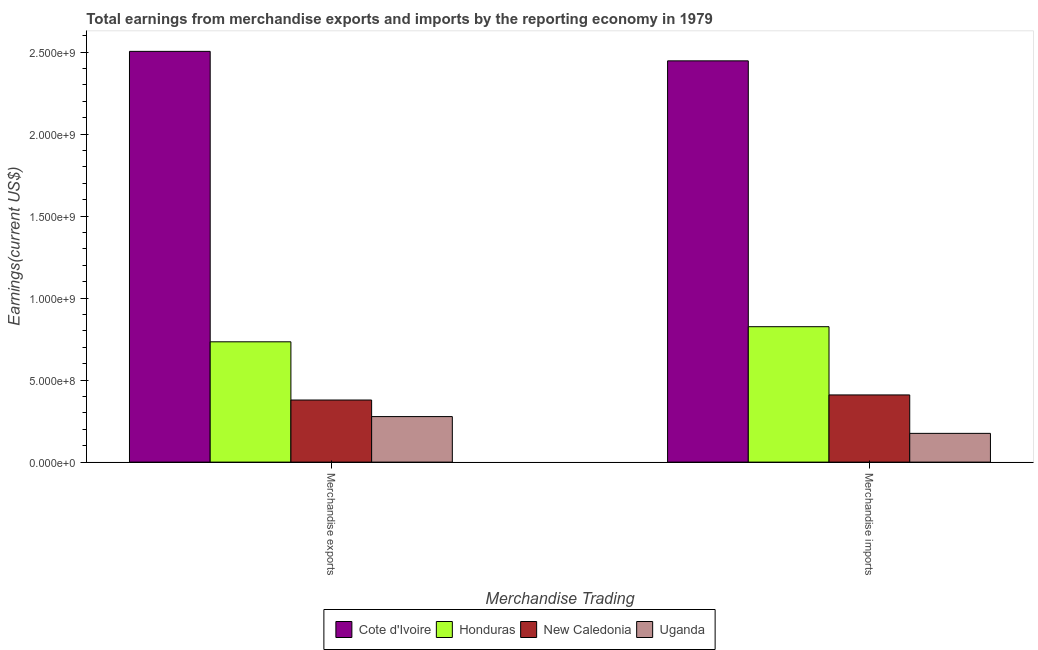How many different coloured bars are there?
Your answer should be very brief. 4. Are the number of bars on each tick of the X-axis equal?
Make the answer very short. Yes. What is the earnings from merchandise exports in Honduras?
Your response must be concise. 7.34e+08. Across all countries, what is the maximum earnings from merchandise exports?
Give a very brief answer. 2.50e+09. Across all countries, what is the minimum earnings from merchandise imports?
Provide a succinct answer. 1.75e+08. In which country was the earnings from merchandise imports maximum?
Your response must be concise. Cote d'Ivoire. In which country was the earnings from merchandise exports minimum?
Make the answer very short. Uganda. What is the total earnings from merchandise imports in the graph?
Your answer should be very brief. 3.86e+09. What is the difference between the earnings from merchandise exports in Uganda and that in Cote d'Ivoire?
Your answer should be compact. -2.23e+09. What is the difference between the earnings from merchandise exports in Cote d'Ivoire and the earnings from merchandise imports in New Caledonia?
Ensure brevity in your answer.  2.09e+09. What is the average earnings from merchandise exports per country?
Offer a terse response. 9.74e+08. What is the difference between the earnings from merchandise imports and earnings from merchandise exports in Honduras?
Ensure brevity in your answer.  9.21e+07. In how many countries, is the earnings from merchandise imports greater than 1100000000 US$?
Give a very brief answer. 1. What is the ratio of the earnings from merchandise exports in New Caledonia to that in Cote d'Ivoire?
Offer a very short reply. 0.15. Is the earnings from merchandise exports in New Caledonia less than that in Cote d'Ivoire?
Provide a succinct answer. Yes. What does the 1st bar from the left in Merchandise imports represents?
Offer a terse response. Cote d'Ivoire. What does the 4th bar from the right in Merchandise exports represents?
Your answer should be compact. Cote d'Ivoire. Are all the bars in the graph horizontal?
Your response must be concise. No. Are the values on the major ticks of Y-axis written in scientific E-notation?
Offer a very short reply. Yes. Does the graph contain any zero values?
Your response must be concise. No. Does the graph contain grids?
Keep it short and to the point. No. Where does the legend appear in the graph?
Make the answer very short. Bottom center. What is the title of the graph?
Ensure brevity in your answer.  Total earnings from merchandise exports and imports by the reporting economy in 1979. Does "United States" appear as one of the legend labels in the graph?
Ensure brevity in your answer.  No. What is the label or title of the X-axis?
Provide a short and direct response. Merchandise Trading. What is the label or title of the Y-axis?
Offer a terse response. Earnings(current US$). What is the Earnings(current US$) of Cote d'Ivoire in Merchandise exports?
Keep it short and to the point. 2.50e+09. What is the Earnings(current US$) in Honduras in Merchandise exports?
Give a very brief answer. 7.34e+08. What is the Earnings(current US$) in New Caledonia in Merchandise exports?
Provide a short and direct response. 3.79e+08. What is the Earnings(current US$) of Uganda in Merchandise exports?
Ensure brevity in your answer.  2.78e+08. What is the Earnings(current US$) of Cote d'Ivoire in Merchandise imports?
Make the answer very short. 2.45e+09. What is the Earnings(current US$) of Honduras in Merchandise imports?
Keep it short and to the point. 8.26e+08. What is the Earnings(current US$) of New Caledonia in Merchandise imports?
Provide a succinct answer. 4.10e+08. What is the Earnings(current US$) in Uganda in Merchandise imports?
Your response must be concise. 1.75e+08. Across all Merchandise Trading, what is the maximum Earnings(current US$) of Cote d'Ivoire?
Offer a terse response. 2.50e+09. Across all Merchandise Trading, what is the maximum Earnings(current US$) in Honduras?
Give a very brief answer. 8.26e+08. Across all Merchandise Trading, what is the maximum Earnings(current US$) in New Caledonia?
Keep it short and to the point. 4.10e+08. Across all Merchandise Trading, what is the maximum Earnings(current US$) of Uganda?
Keep it short and to the point. 2.78e+08. Across all Merchandise Trading, what is the minimum Earnings(current US$) in Cote d'Ivoire?
Make the answer very short. 2.45e+09. Across all Merchandise Trading, what is the minimum Earnings(current US$) in Honduras?
Keep it short and to the point. 7.34e+08. Across all Merchandise Trading, what is the minimum Earnings(current US$) of New Caledonia?
Give a very brief answer. 3.79e+08. Across all Merchandise Trading, what is the minimum Earnings(current US$) in Uganda?
Keep it short and to the point. 1.75e+08. What is the total Earnings(current US$) in Cote d'Ivoire in the graph?
Provide a succinct answer. 4.95e+09. What is the total Earnings(current US$) of Honduras in the graph?
Give a very brief answer. 1.56e+09. What is the total Earnings(current US$) in New Caledonia in the graph?
Keep it short and to the point. 7.88e+08. What is the total Earnings(current US$) in Uganda in the graph?
Provide a short and direct response. 4.53e+08. What is the difference between the Earnings(current US$) of Cote d'Ivoire in Merchandise exports and that in Merchandise imports?
Offer a very short reply. 5.79e+07. What is the difference between the Earnings(current US$) of Honduras in Merchandise exports and that in Merchandise imports?
Your answer should be compact. -9.21e+07. What is the difference between the Earnings(current US$) in New Caledonia in Merchandise exports and that in Merchandise imports?
Give a very brief answer. -3.11e+07. What is the difference between the Earnings(current US$) of Uganda in Merchandise exports and that in Merchandise imports?
Offer a terse response. 1.02e+08. What is the difference between the Earnings(current US$) of Cote d'Ivoire in Merchandise exports and the Earnings(current US$) of Honduras in Merchandise imports?
Your answer should be very brief. 1.68e+09. What is the difference between the Earnings(current US$) in Cote d'Ivoire in Merchandise exports and the Earnings(current US$) in New Caledonia in Merchandise imports?
Provide a short and direct response. 2.09e+09. What is the difference between the Earnings(current US$) in Cote d'Ivoire in Merchandise exports and the Earnings(current US$) in Uganda in Merchandise imports?
Make the answer very short. 2.33e+09. What is the difference between the Earnings(current US$) in Honduras in Merchandise exports and the Earnings(current US$) in New Caledonia in Merchandise imports?
Offer a very short reply. 3.24e+08. What is the difference between the Earnings(current US$) in Honduras in Merchandise exports and the Earnings(current US$) in Uganda in Merchandise imports?
Give a very brief answer. 5.58e+08. What is the difference between the Earnings(current US$) in New Caledonia in Merchandise exports and the Earnings(current US$) in Uganda in Merchandise imports?
Provide a succinct answer. 2.03e+08. What is the average Earnings(current US$) in Cote d'Ivoire per Merchandise Trading?
Provide a short and direct response. 2.48e+09. What is the average Earnings(current US$) of Honduras per Merchandise Trading?
Make the answer very short. 7.80e+08. What is the average Earnings(current US$) of New Caledonia per Merchandise Trading?
Offer a very short reply. 3.94e+08. What is the average Earnings(current US$) in Uganda per Merchandise Trading?
Keep it short and to the point. 2.27e+08. What is the difference between the Earnings(current US$) of Cote d'Ivoire and Earnings(current US$) of Honduras in Merchandise exports?
Offer a terse response. 1.77e+09. What is the difference between the Earnings(current US$) of Cote d'Ivoire and Earnings(current US$) of New Caledonia in Merchandise exports?
Ensure brevity in your answer.  2.13e+09. What is the difference between the Earnings(current US$) of Cote d'Ivoire and Earnings(current US$) of Uganda in Merchandise exports?
Offer a very short reply. 2.23e+09. What is the difference between the Earnings(current US$) of Honduras and Earnings(current US$) of New Caledonia in Merchandise exports?
Provide a succinct answer. 3.55e+08. What is the difference between the Earnings(current US$) of Honduras and Earnings(current US$) of Uganda in Merchandise exports?
Offer a terse response. 4.56e+08. What is the difference between the Earnings(current US$) of New Caledonia and Earnings(current US$) of Uganda in Merchandise exports?
Provide a succinct answer. 1.01e+08. What is the difference between the Earnings(current US$) in Cote d'Ivoire and Earnings(current US$) in Honduras in Merchandise imports?
Make the answer very short. 1.62e+09. What is the difference between the Earnings(current US$) in Cote d'Ivoire and Earnings(current US$) in New Caledonia in Merchandise imports?
Your answer should be very brief. 2.04e+09. What is the difference between the Earnings(current US$) of Cote d'Ivoire and Earnings(current US$) of Uganda in Merchandise imports?
Ensure brevity in your answer.  2.27e+09. What is the difference between the Earnings(current US$) of Honduras and Earnings(current US$) of New Caledonia in Merchandise imports?
Provide a short and direct response. 4.16e+08. What is the difference between the Earnings(current US$) in Honduras and Earnings(current US$) in Uganda in Merchandise imports?
Give a very brief answer. 6.50e+08. What is the difference between the Earnings(current US$) of New Caledonia and Earnings(current US$) of Uganda in Merchandise imports?
Keep it short and to the point. 2.34e+08. What is the ratio of the Earnings(current US$) of Cote d'Ivoire in Merchandise exports to that in Merchandise imports?
Your response must be concise. 1.02. What is the ratio of the Earnings(current US$) in Honduras in Merchandise exports to that in Merchandise imports?
Your answer should be very brief. 0.89. What is the ratio of the Earnings(current US$) in New Caledonia in Merchandise exports to that in Merchandise imports?
Your response must be concise. 0.92. What is the ratio of the Earnings(current US$) in Uganda in Merchandise exports to that in Merchandise imports?
Your response must be concise. 1.58. What is the difference between the highest and the second highest Earnings(current US$) of Cote d'Ivoire?
Make the answer very short. 5.79e+07. What is the difference between the highest and the second highest Earnings(current US$) of Honduras?
Give a very brief answer. 9.21e+07. What is the difference between the highest and the second highest Earnings(current US$) in New Caledonia?
Your answer should be compact. 3.11e+07. What is the difference between the highest and the second highest Earnings(current US$) in Uganda?
Your answer should be compact. 1.02e+08. What is the difference between the highest and the lowest Earnings(current US$) in Cote d'Ivoire?
Provide a short and direct response. 5.79e+07. What is the difference between the highest and the lowest Earnings(current US$) in Honduras?
Give a very brief answer. 9.21e+07. What is the difference between the highest and the lowest Earnings(current US$) of New Caledonia?
Ensure brevity in your answer.  3.11e+07. What is the difference between the highest and the lowest Earnings(current US$) of Uganda?
Provide a short and direct response. 1.02e+08. 